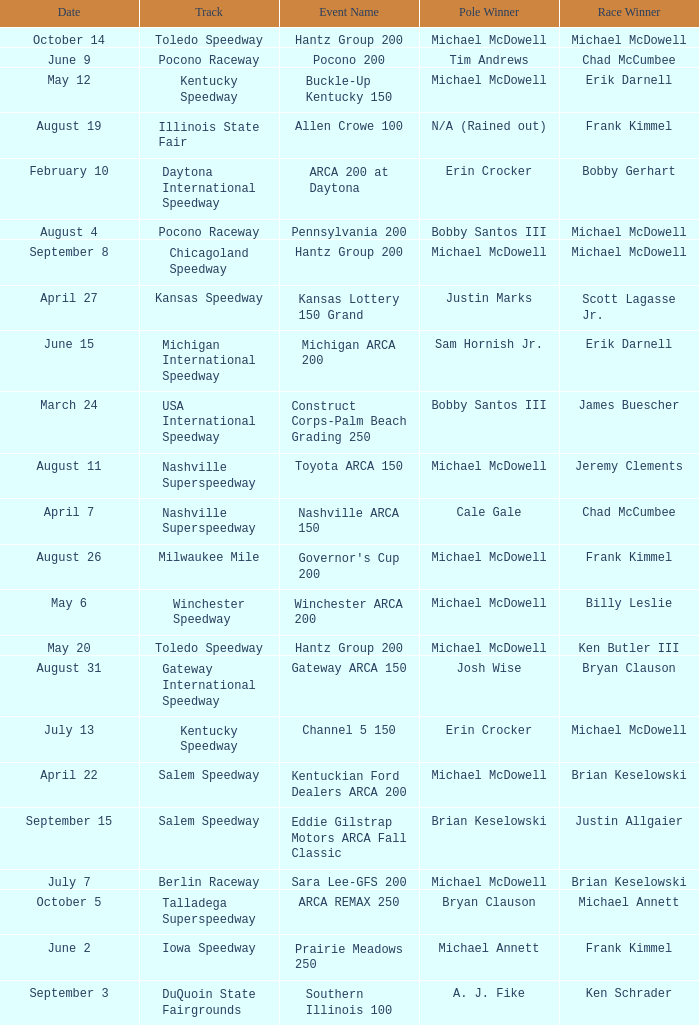Tell me the pole winner of may 12 Michael McDowell. 